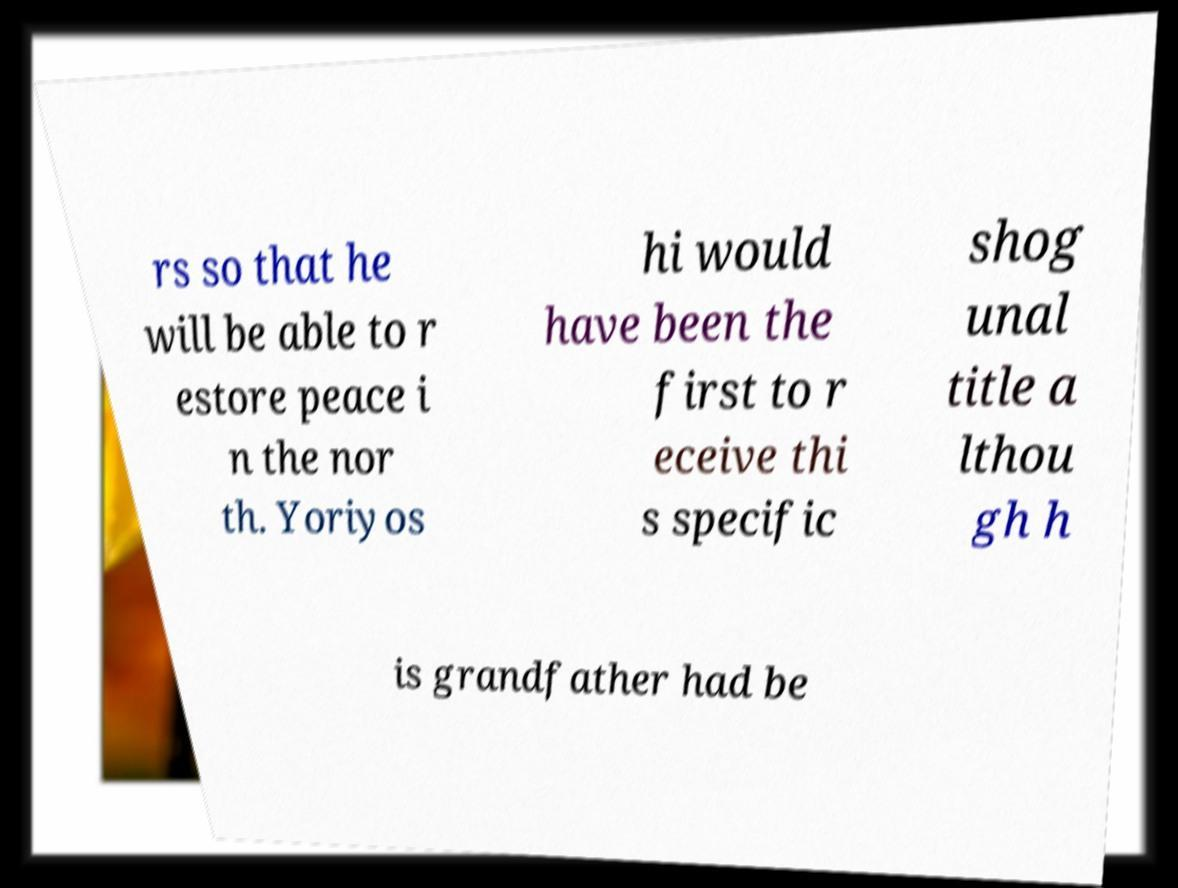Please read and relay the text visible in this image. What does it say? rs so that he will be able to r estore peace i n the nor th. Yoriyos hi would have been the first to r eceive thi s specific shog unal title a lthou gh h is grandfather had be 